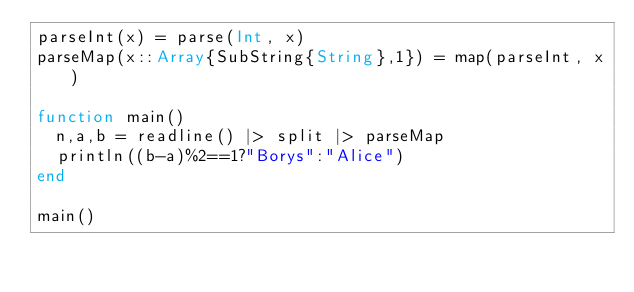Convert code to text. <code><loc_0><loc_0><loc_500><loc_500><_Julia_>parseInt(x) = parse(Int, x)
parseMap(x::Array{SubString{String},1}) = map(parseInt, x)

function main()
	n,a,b = readline() |> split |> parseMap
	println((b-a)%2==1?"Borys":"Alice")
end

main()
</code> 